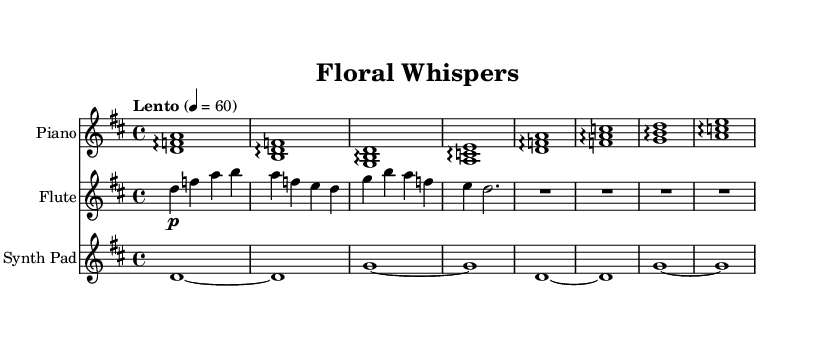What is the key signature of this music? The key signature is indicated at the beginning of the staff, and it shows two sharps (F# and C#), which defines the key of D major.
Answer: D major What is the time signature of this piece? The time signature is shown at the beginning of the score and is indicated as 4/4, meaning there are four beats per measure.
Answer: 4/4 What is the tempo marking for this composition? The tempo marking is provided in Italian at the beginning of the score, indicating the speed of the piece as "Lento," which means slow.
Answer: Lento How many measures does the piano part contain? By counting the measures in the piano part written in the score, there are a total of 8 measures.
Answer: 8 What instruments are featured in this piece? The instruments are specified at the beginning of each staff in the score, which shows piano, flute, and synth pad as the featured instruments.
Answer: Piano, Flute, Synth Pad Which section of the piece features rests? The rests can be observed in the flute part, specifically indicated as whole rests following the notes. This is where no sound is produced, creating a moment of silence in the music.
Answer: Flute What kind of musical elements are used to create an atmospheric vibe in this piece? The use of arpeggios, long sustained notes, and soft dynamics in the piano, flute, and synth pad culminates in a soothing and ambient atmosphere reminiscent of a flower shop's tranquility.
Answer: Arpeggios, sustained notes, soft dynamics 